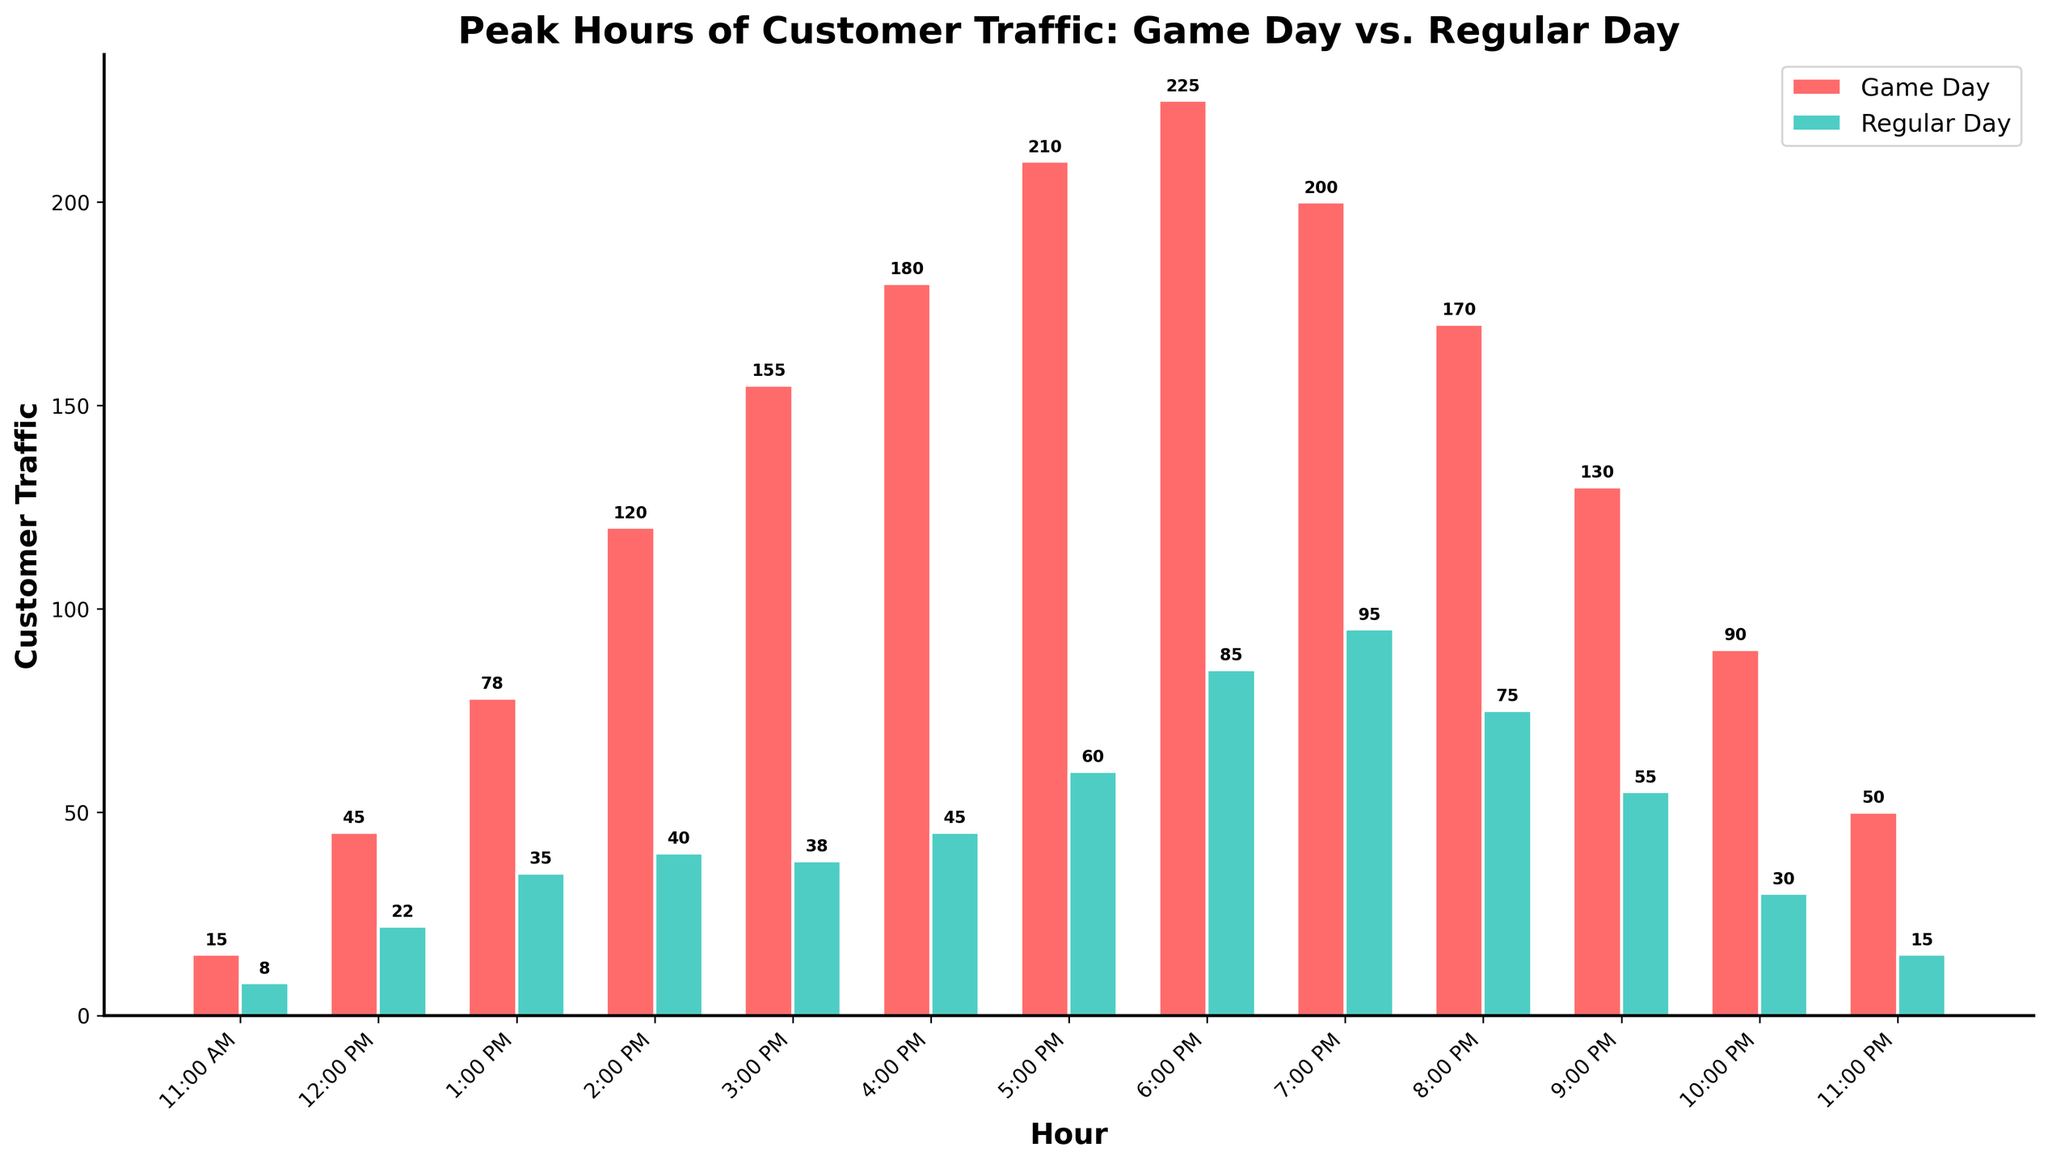What is the difference in customer traffic between game days and regular days at 2:00 PM? At 2:00 PM, game day traffic is 120 and regular day traffic is 40. The difference is 120 - 40 = 80
Answer: 80 Which hour experiences the highest customer traffic on game days? By examining the heights of the bars, the highest customer traffic on game days is at 6:00 PM with a traffic count of 225
Answer: 6:00 PM How does customer traffic at 5:00 PM on game days compare to regular days? At 5:00 PM, game day traffic is 210 and regular day traffic is 60. Therefore, 210 is greater than 60, indicating more traffic on game days
Answer: Game days have more traffic At what time does customer traffic start to decline on game days? Traffic on game days increases until 6:00 PM (225) and then begins to decline starting from 7:00 PM (200)
Answer: 7:00 PM What is the total customer traffic from 11:00 AM to 4:00 PM on regular days? Adding up the regular day traffic from 11:00 AM to 4:00 PM: 8 + 22 + 35 + 40 + 38 + 45 = 188
Answer: 188 Does customer traffic peak later on game days or regular days? On game days, traffic peaks at 6:00 PM, whereas on regular days, it peaks at 7:00 PM. Thus, traffic peaks later on regular days
Answer: Regular days Which hour has the smallest difference in traffic between game days and regular days? By calculating the differences for each hour, the smallest difference is at 3:00 PM, where game day traffic is 155 and regular day traffic is 38: 155 - 38 = 117
Answer: 3:00 PM Between which two consecutive hours does the game day traffic increase the most? The largest increase on game days is from 2:00 PM (120) to 3:00 PM (155), a difference of 155 - 120 = 35
Answer: 2:00 PM to 3:00 PM What are the customer traffic numbers for 8:00 PM on game days and regular days? From the bars corresponding to 8:00 PM, game day traffic is 170 and regular day traffic is 75
Answer: 170 and 75 